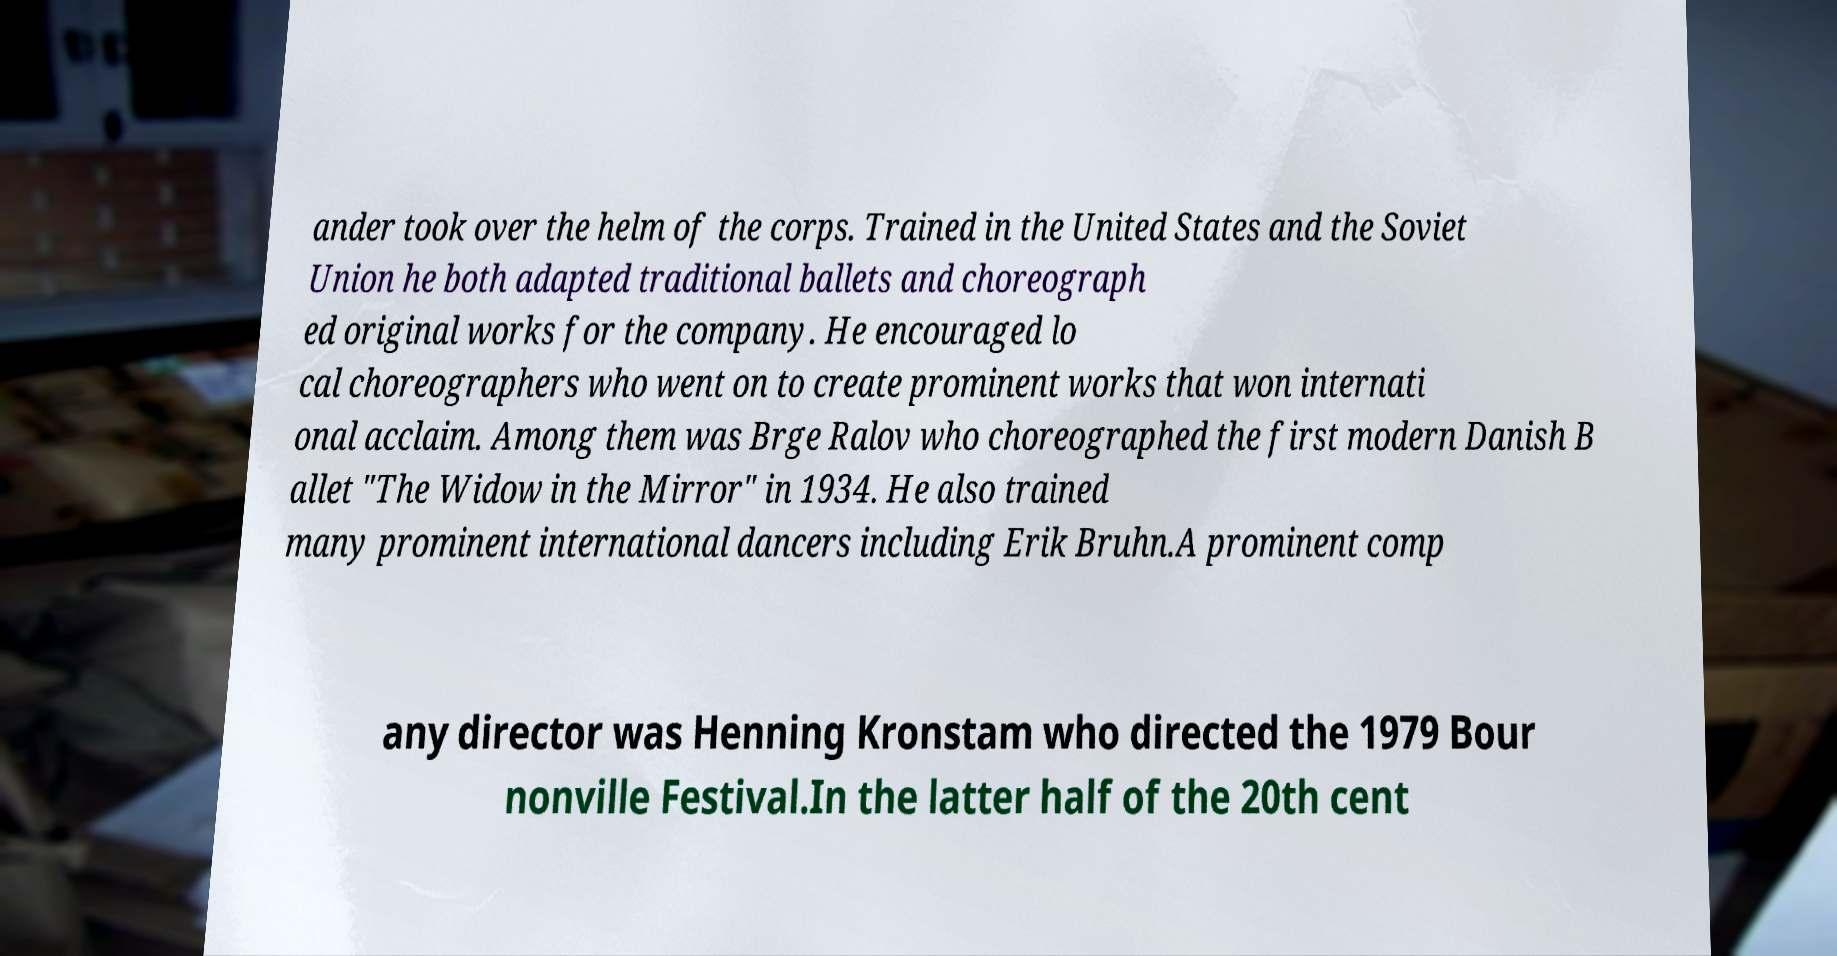I need the written content from this picture converted into text. Can you do that? ander took over the helm of the corps. Trained in the United States and the Soviet Union he both adapted traditional ballets and choreograph ed original works for the company. He encouraged lo cal choreographers who went on to create prominent works that won internati onal acclaim. Among them was Brge Ralov who choreographed the first modern Danish B allet "The Widow in the Mirror" in 1934. He also trained many prominent international dancers including Erik Bruhn.A prominent comp any director was Henning Kronstam who directed the 1979 Bour nonville Festival.In the latter half of the 20th cent 